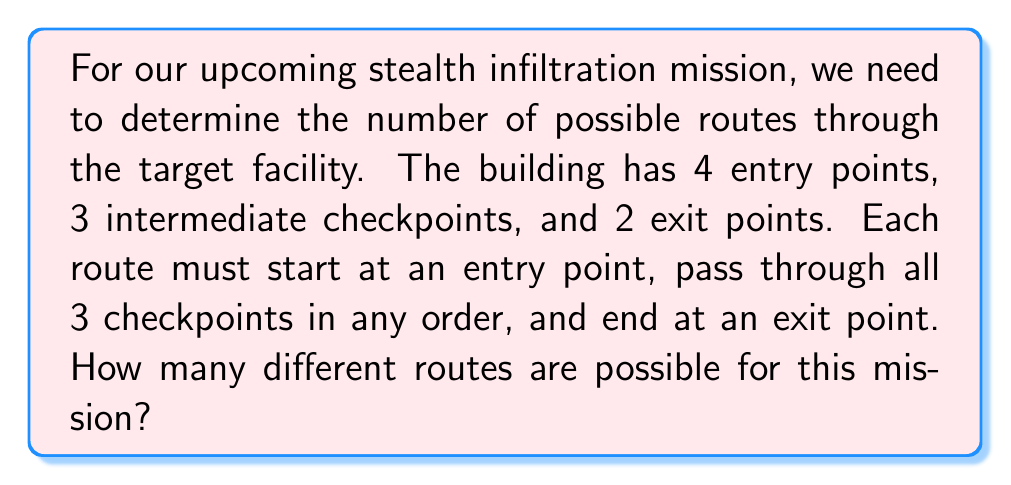Teach me how to tackle this problem. Let's break this down step-by-step:

1) First, we need to choose an entry point. There are 4 options for this.

2) Next, we need to arrange the 3 checkpoints. This is a permutation of 3 items, which is calculated as:
   $$P(3,3) = 3! = 3 \times 2 \times 1 = 6$$

3) Finally, we need to choose an exit point. There are 2 options for this.

4) According to the multiplication principle, if we have a sequence of choices where there are $m$ ways of making the first choice, $n$ ways of making the second choice, and $p$ ways of making the third choice, then there are $m \times n \times p$ ways of making the sequence of choices.

5) Therefore, the total number of possible routes is:
   $$4 \times 6 \times 2 = 48$$

This calculation can be written as:
$$\text{Number of routes} = \text{(Entry points)} \times \text{(Checkpoint permutations)} \times \text{(Exit points)}$$
$$= 4 \times P(3,3) \times 2$$
$$= 4 \times 3! \times 2$$
$$= 4 \times 6 \times 2 = 48$$
Answer: 48 routes 